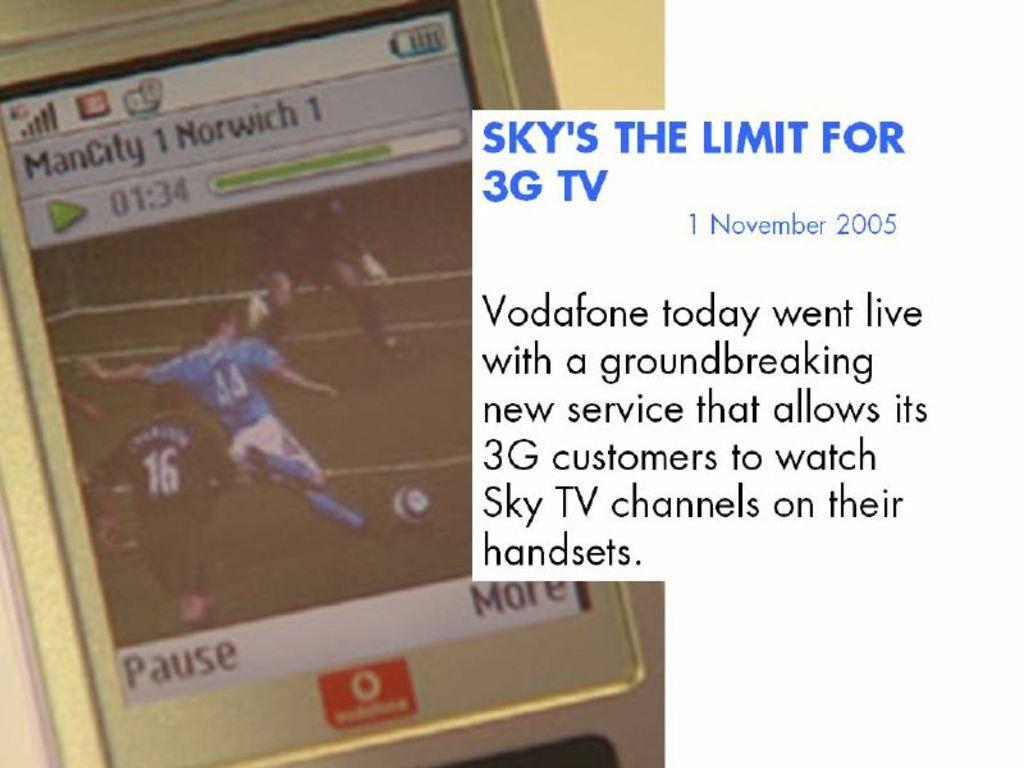<image>
Summarize the visual content of the image. An ad for Vodafone is dated the first of November 2005. 